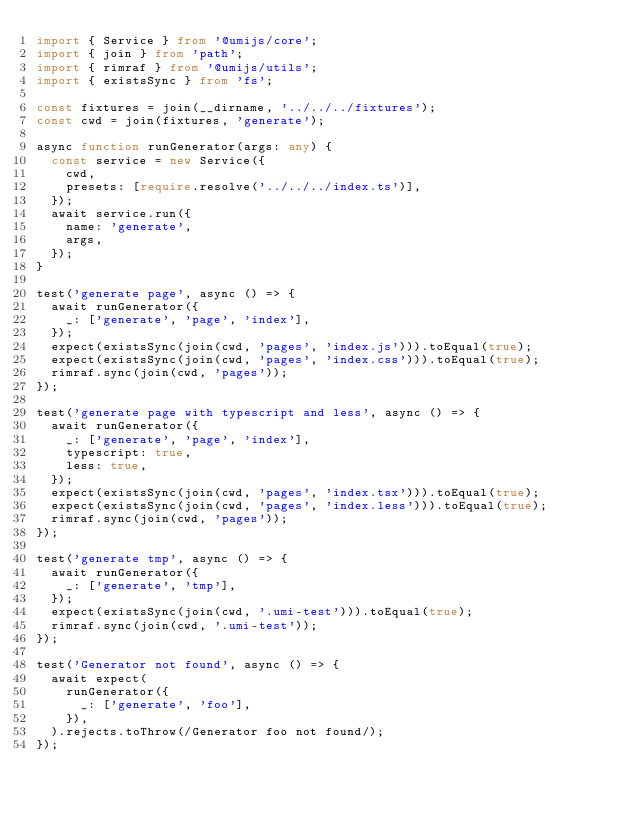<code> <loc_0><loc_0><loc_500><loc_500><_TypeScript_>import { Service } from '@umijs/core';
import { join } from 'path';
import { rimraf } from '@umijs/utils';
import { existsSync } from 'fs';

const fixtures = join(__dirname, '../../../fixtures');
const cwd = join(fixtures, 'generate');

async function runGenerator(args: any) {
  const service = new Service({
    cwd,
    presets: [require.resolve('../../../index.ts')],
  });
  await service.run({
    name: 'generate',
    args,
  });
}

test('generate page', async () => {
  await runGenerator({
    _: ['generate', 'page', 'index'],
  });
  expect(existsSync(join(cwd, 'pages', 'index.js'))).toEqual(true);
  expect(existsSync(join(cwd, 'pages', 'index.css'))).toEqual(true);
  rimraf.sync(join(cwd, 'pages'));
});

test('generate page with typescript and less', async () => {
  await runGenerator({
    _: ['generate', 'page', 'index'],
    typescript: true,
    less: true,
  });
  expect(existsSync(join(cwd, 'pages', 'index.tsx'))).toEqual(true);
  expect(existsSync(join(cwd, 'pages', 'index.less'))).toEqual(true);
  rimraf.sync(join(cwd, 'pages'));
});

test('generate tmp', async () => {
  await runGenerator({
    _: ['generate', 'tmp'],
  });
  expect(existsSync(join(cwd, '.umi-test'))).toEqual(true);
  rimraf.sync(join(cwd, '.umi-test'));
});

test('Generator not found', async () => {
  await expect(
    runGenerator({
      _: ['generate', 'foo'],
    }),
  ).rejects.toThrow(/Generator foo not found/);
});
</code> 